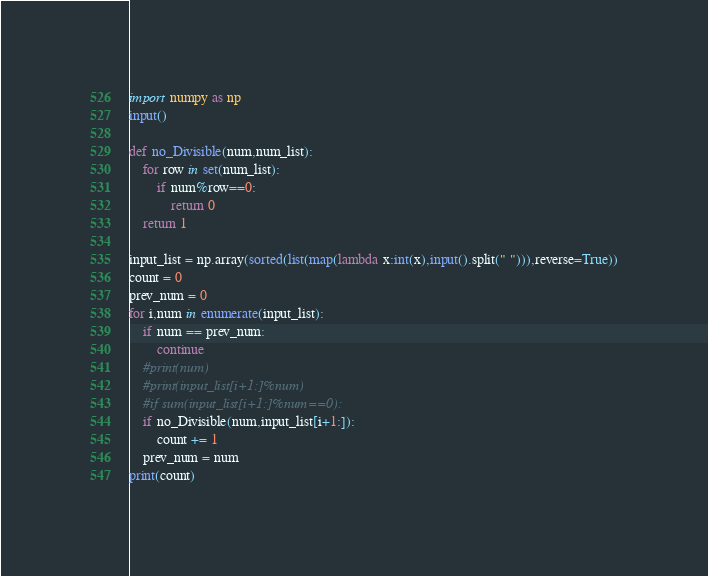Convert code to text. <code><loc_0><loc_0><loc_500><loc_500><_Python_>import numpy as np
input()

def no_Divisible(num,num_list):
    for row in set(num_list):
        if num%row==0:
            return 0
    return 1

input_list = np.array(sorted(list(map(lambda x:int(x),input().split(" "))),reverse=True))
count = 0
prev_num = 0
for i,num in enumerate(input_list):
    if num == prev_num:
        continue
    #print(num)
    #print(input_list[i+1:]%num)
    #if sum(input_list[i+1:]%num==0):
    if no_Divisible(num,input_list[i+1:]):
        count += 1
    prev_num = num
print(count)

</code> 